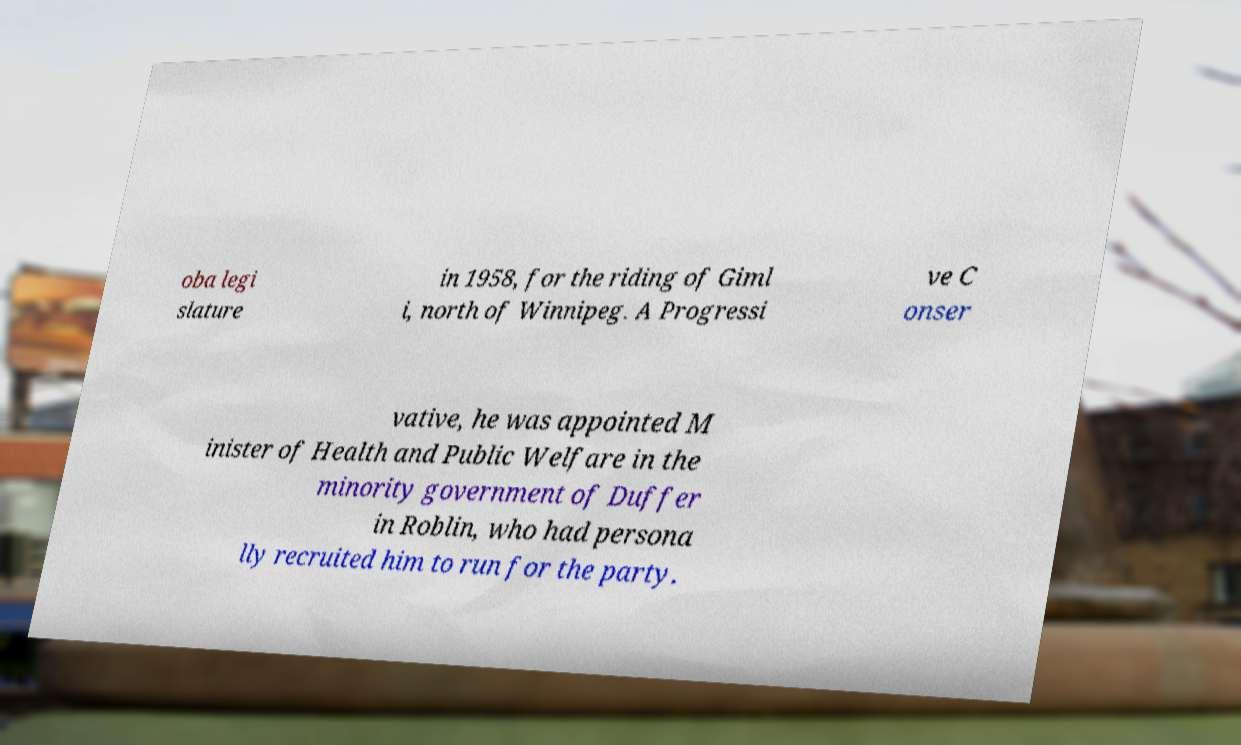Can you accurately transcribe the text from the provided image for me? oba legi slature in 1958, for the riding of Giml i, north of Winnipeg. A Progressi ve C onser vative, he was appointed M inister of Health and Public Welfare in the minority government of Duffer in Roblin, who had persona lly recruited him to run for the party. 